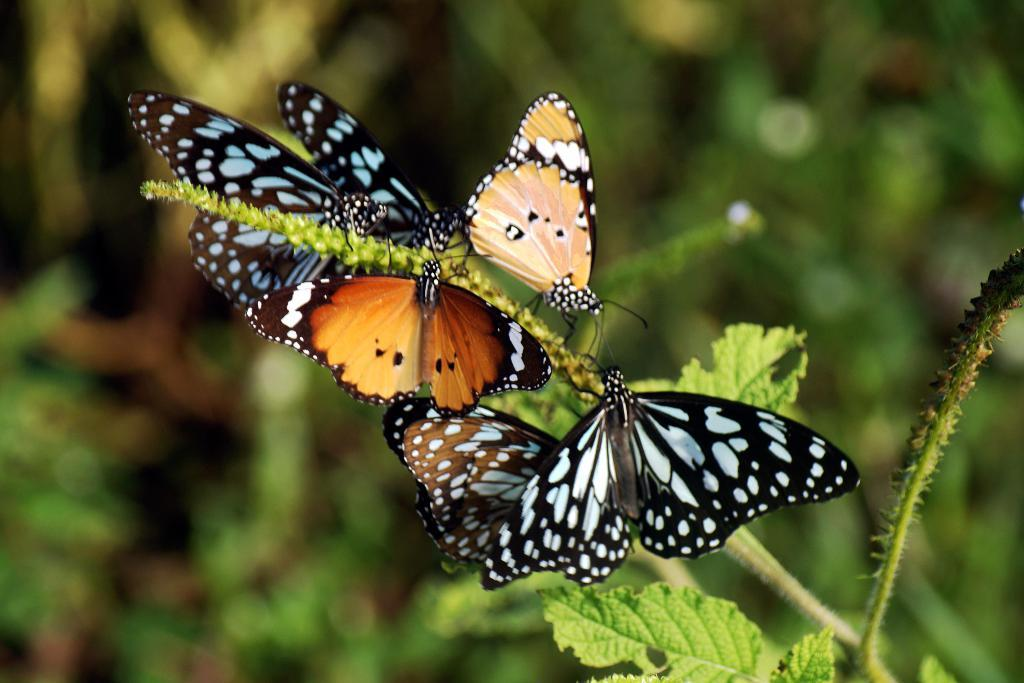What type of animals can be seen in the image? There are butterflies in the image. What can be seen in the background of the image? There are trees in the background of the image. How would you describe the appearance of the background? The background appears blurry. How many memories are visible in the image? There are no memories present in the image; it features butterflies and trees in the background. What type of flock is flying in the image? There is no flock of animals present in the image; it features butterflies, which are individual insects. 